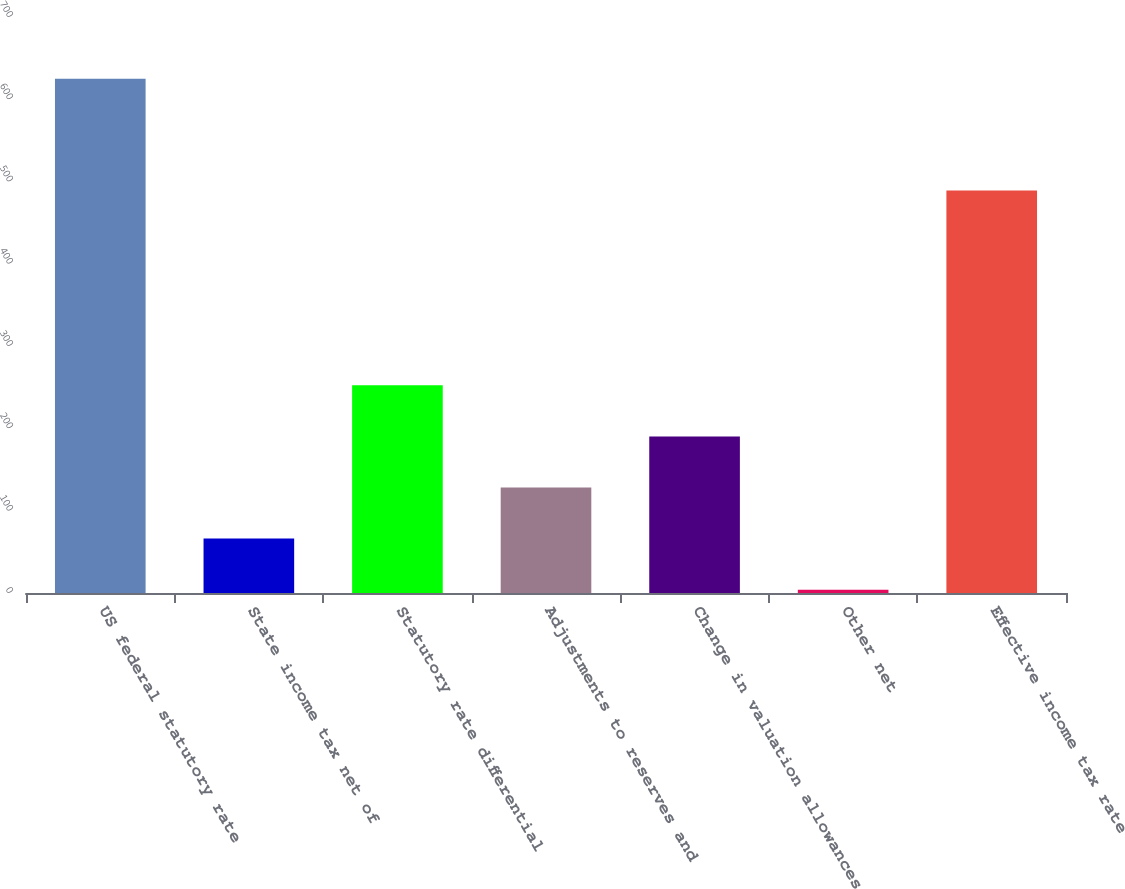Convert chart to OTSL. <chart><loc_0><loc_0><loc_500><loc_500><bar_chart><fcel>US federal statutory rate<fcel>State income tax net of<fcel>Statutory rate differential<fcel>Adjustments to reserves and<fcel>Change in valuation allowances<fcel>Other net<fcel>Effective income tax rate<nl><fcel>625<fcel>66.1<fcel>252.4<fcel>128.2<fcel>190.3<fcel>4<fcel>489<nl></chart> 